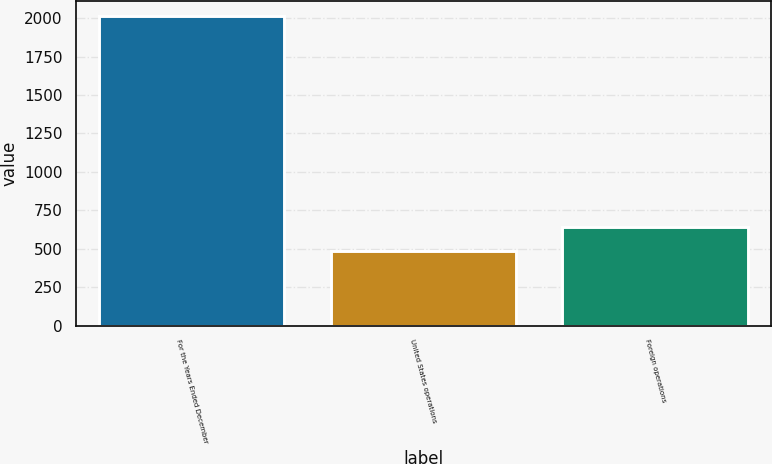<chart> <loc_0><loc_0><loc_500><loc_500><bar_chart><fcel>For the Years Ended December<fcel>United States operations<fcel>Foreign operations<nl><fcel>2011<fcel>485.7<fcel>638.23<nl></chart> 